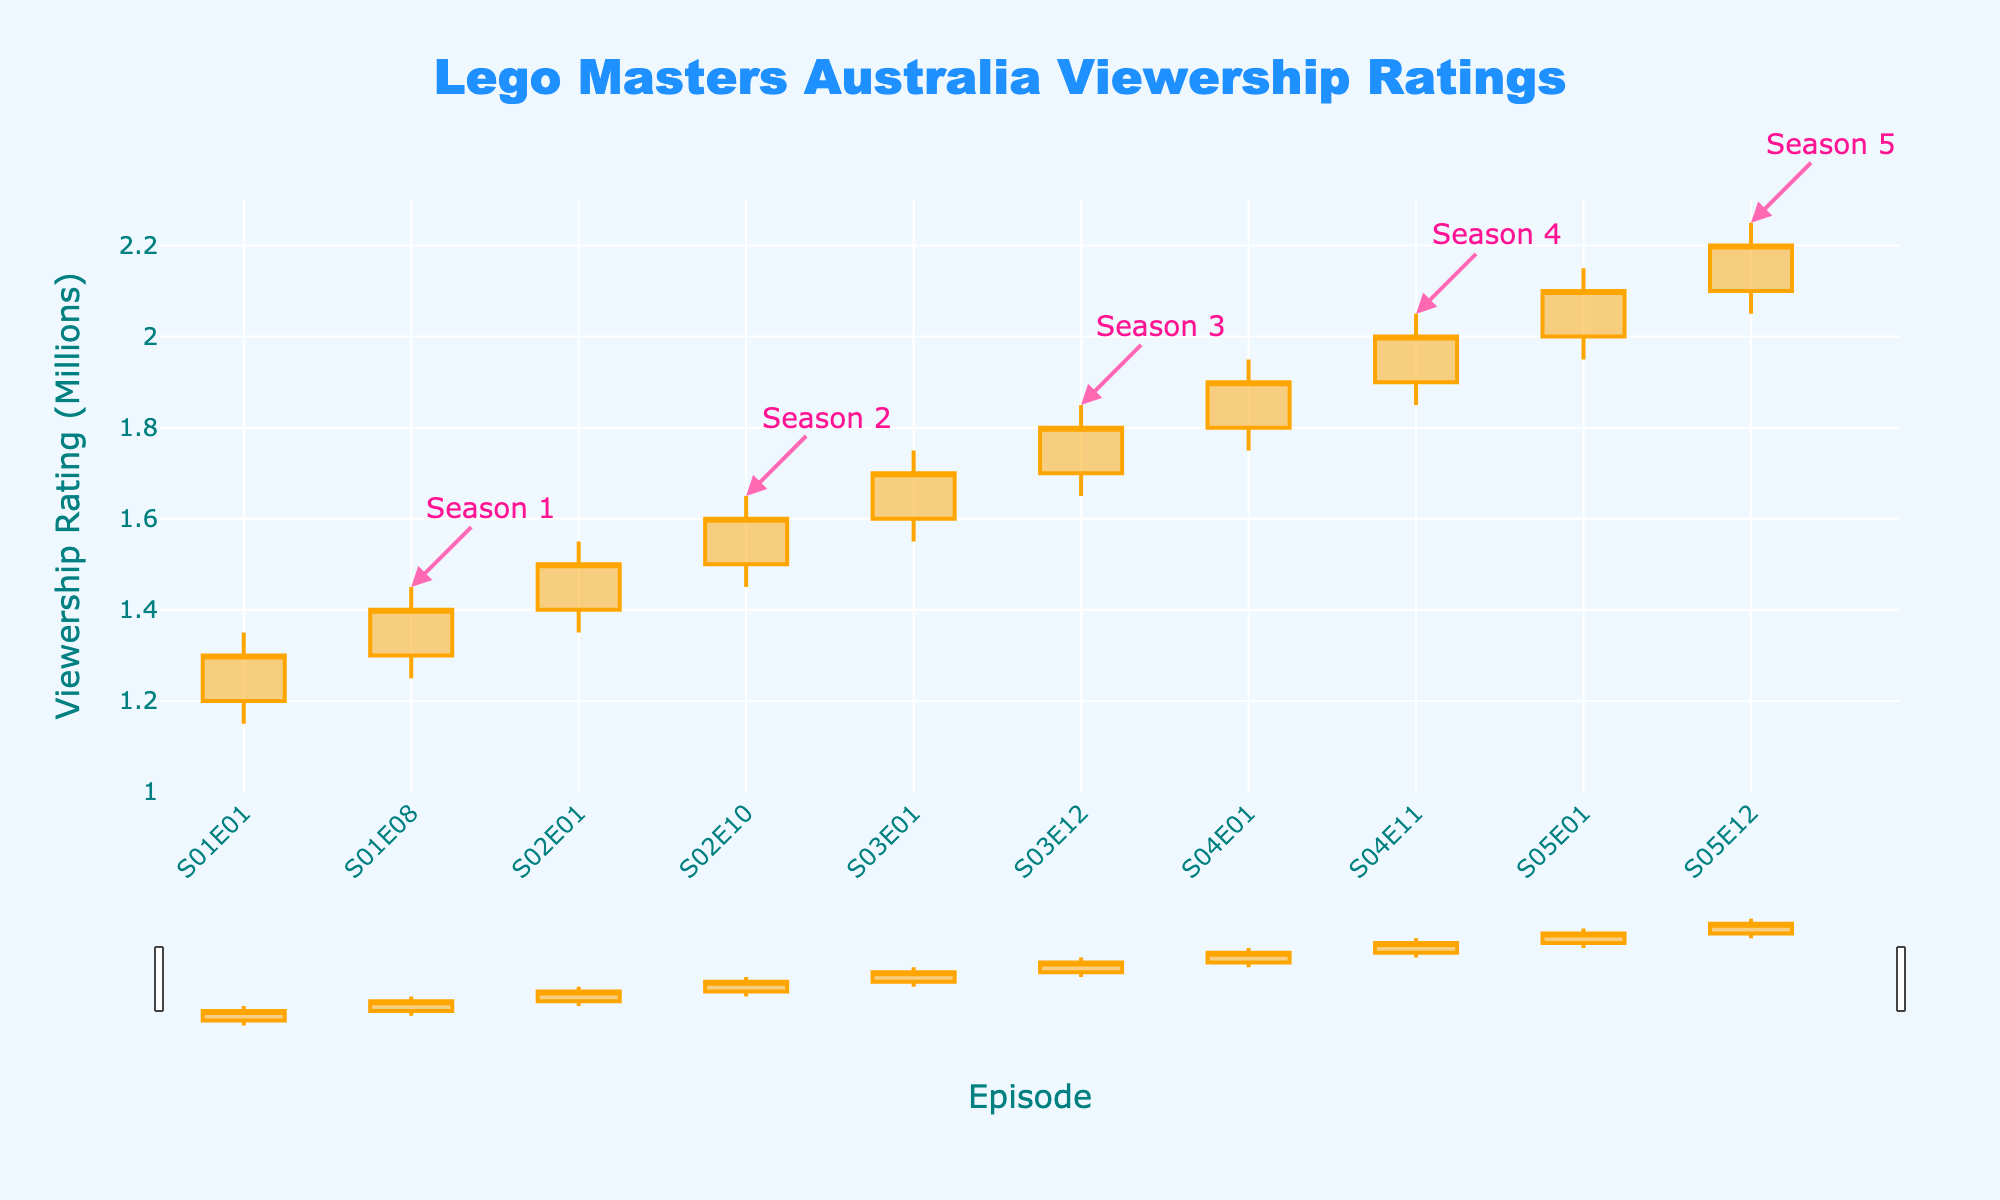What is the title of the plot? The title is displayed at the top center of the plot. It reads "Lego Masters Australia Viewership Ratings".
Answer: Lego Masters Australia Viewership Ratings How many episodes are presented in each season? By counting the unique episodes for each season on the x-axis, we can determine that Season 1 has 2 episodes, Season 2 has 2 episodes, Season 3 has 2 episodes, Season 4 has 2 episodes, and Season 5 has 2 episodes.
Answer: 2 episodes per season Which episode has the highest viewership rating? By looking at the highest value on the 'High' attribute of the OHLC plot, S05E12 has the maximum value of 2.25 million.
Answer: S05E12 How did the viewership trend change from the first to the last episode of each season? We need to check the 'Open' and 'Close' values for the first and last episodes in each season. Season 1: 1.20 to 1.40, Season 2: 1.40 to 1.60, Season 3: 1.60 to 1.80, Season 4: 1.80 to 2.00, and Season 5: 2.00 to 2.20. For all seasons, the viewership increased.
Answer: Increased What is the viewership range for Season 3? The viewership range can be determined by finding the difference between the highest 'High' value and the lowest 'Low' value for Season 3. The highest is 1.85 million (S03E12) and the lowest is 1.55 million (S03E01). Thus, the range is 1.85 - 1.55 = 0.30 million.
Answer: 0.30 million In which season did the closing episode have the highest viewership rating compared to its opening episode? We need to compare the 'Open' and 'Close' values of the closing episode in each season. The largest increase is seen in Season 4, where the 'Open' is 1.80 million in S04E01 and 'Close' is 2.00 million in S04E11.
Answer: Season 4 What is the minimum viewership rating recorded across all episodes? By inspecting the 'Low' attribute of the OHLC chart, the minimum value observed is 1.15 million in S01E01.
Answer: 1.15 million Which season shows the smallest difference between the opening and closing episodes' viewership ratings? Calculate the difference between 'Open' and 'Close' for the first and last episodes of each season and find the smallest one. Season 1: 1.40 - 1.20 = 0.20, Season 2: 1.60 - 1.40 = 0.20, Season 3: 1.80 - 1.60 = 0.20, Season 4: 2.00 - 1.80 = 0.20, Season 5: 2.20 - 2.00 = 0.20. All seasons have the same difference of 0.20 million.
Answer: 0.20 million (all seasons) How does the viewership of the first episode of Season 2 compare to the last episode of Season 1? Check the 'Close' value of S01E08 (1.40M) and the 'Open' value of S02E01 (1.40M). They are equal.
Answer: Equal What is the overall trend observed in viewership ratings from Season 1 to Season 5? By examining the 'Close' values of the last episodes of each season, we see an overall increasing trend from 1.40M (S01E08), 1.60M (S02E10), 1.80M (S03E12), 2.00M (S04E11), to 2.20M (S05E12).
Answer: Increasing 